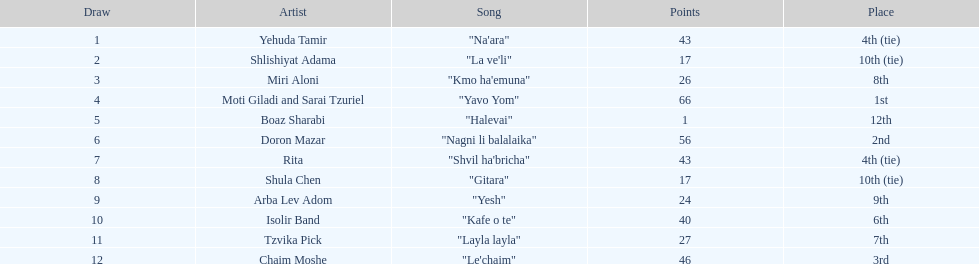Which draw had the lowest number of points? Boaz Sharabi. 